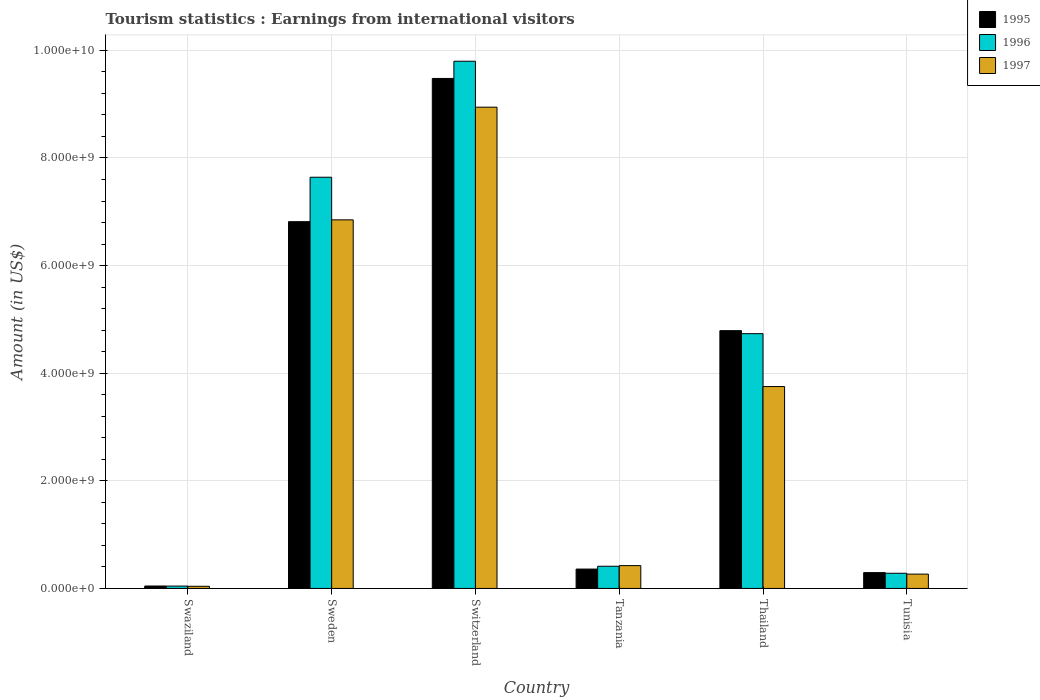How many different coloured bars are there?
Your answer should be compact. 3. How many groups of bars are there?
Provide a succinct answer. 6. Are the number of bars per tick equal to the number of legend labels?
Make the answer very short. Yes. Are the number of bars on each tick of the X-axis equal?
Your response must be concise. Yes. How many bars are there on the 4th tick from the left?
Make the answer very short. 3. How many bars are there on the 6th tick from the right?
Make the answer very short. 3. What is the label of the 2nd group of bars from the left?
Your answer should be compact. Sweden. In how many cases, is the number of bars for a given country not equal to the number of legend labels?
Provide a short and direct response. 0. What is the earnings from international visitors in 1995 in Switzerland?
Keep it short and to the point. 9.48e+09. Across all countries, what is the maximum earnings from international visitors in 1997?
Offer a very short reply. 8.94e+09. Across all countries, what is the minimum earnings from international visitors in 1997?
Keep it short and to the point. 4.00e+07. In which country was the earnings from international visitors in 1995 maximum?
Offer a terse response. Switzerland. In which country was the earnings from international visitors in 1996 minimum?
Offer a very short reply. Swaziland. What is the total earnings from international visitors in 1995 in the graph?
Offer a very short reply. 2.18e+1. What is the difference between the earnings from international visitors in 1995 in Tanzania and that in Thailand?
Offer a terse response. -4.43e+09. What is the difference between the earnings from international visitors in 1996 in Thailand and the earnings from international visitors in 1995 in Swaziland?
Provide a short and direct response. 4.69e+09. What is the average earnings from international visitors in 1997 per country?
Ensure brevity in your answer.  3.38e+09. What is the difference between the earnings from international visitors of/in 1997 and earnings from international visitors of/in 1995 in Thailand?
Make the answer very short. -1.04e+09. Is the earnings from international visitors in 1995 in Swaziland less than that in Tunisia?
Your answer should be very brief. Yes. What is the difference between the highest and the second highest earnings from international visitors in 1996?
Keep it short and to the point. 2.16e+09. What is the difference between the highest and the lowest earnings from international visitors in 1997?
Your response must be concise. 8.90e+09. In how many countries, is the earnings from international visitors in 1996 greater than the average earnings from international visitors in 1996 taken over all countries?
Ensure brevity in your answer.  3. Are all the bars in the graph horizontal?
Offer a very short reply. No. Does the graph contain any zero values?
Your response must be concise. No. How many legend labels are there?
Ensure brevity in your answer.  3. What is the title of the graph?
Offer a terse response. Tourism statistics : Earnings from international visitors. What is the label or title of the Y-axis?
Make the answer very short. Amount (in US$). What is the Amount (in US$) in 1995 in Swaziland?
Give a very brief answer. 4.50e+07. What is the Amount (in US$) in 1996 in Swaziland?
Offer a terse response. 4.40e+07. What is the Amount (in US$) of 1997 in Swaziland?
Keep it short and to the point. 4.00e+07. What is the Amount (in US$) of 1995 in Sweden?
Make the answer very short. 6.82e+09. What is the Amount (in US$) in 1996 in Sweden?
Keep it short and to the point. 7.64e+09. What is the Amount (in US$) of 1997 in Sweden?
Provide a short and direct response. 6.85e+09. What is the Amount (in US$) in 1995 in Switzerland?
Offer a very short reply. 9.48e+09. What is the Amount (in US$) in 1996 in Switzerland?
Provide a succinct answer. 9.80e+09. What is the Amount (in US$) in 1997 in Switzerland?
Offer a very short reply. 8.94e+09. What is the Amount (in US$) of 1995 in Tanzania?
Make the answer very short. 3.60e+08. What is the Amount (in US$) in 1996 in Tanzania?
Offer a very short reply. 4.12e+08. What is the Amount (in US$) of 1997 in Tanzania?
Provide a short and direct response. 4.24e+08. What is the Amount (in US$) in 1995 in Thailand?
Your response must be concise. 4.79e+09. What is the Amount (in US$) of 1996 in Thailand?
Offer a very short reply. 4.74e+09. What is the Amount (in US$) in 1997 in Thailand?
Provide a short and direct response. 3.75e+09. What is the Amount (in US$) of 1995 in Tunisia?
Ensure brevity in your answer.  2.94e+08. What is the Amount (in US$) of 1996 in Tunisia?
Ensure brevity in your answer.  2.82e+08. What is the Amount (in US$) in 1997 in Tunisia?
Give a very brief answer. 2.66e+08. Across all countries, what is the maximum Amount (in US$) in 1995?
Provide a short and direct response. 9.48e+09. Across all countries, what is the maximum Amount (in US$) in 1996?
Offer a terse response. 9.80e+09. Across all countries, what is the maximum Amount (in US$) in 1997?
Offer a terse response. 8.94e+09. Across all countries, what is the minimum Amount (in US$) in 1995?
Your answer should be compact. 4.50e+07. Across all countries, what is the minimum Amount (in US$) in 1996?
Ensure brevity in your answer.  4.40e+07. Across all countries, what is the minimum Amount (in US$) in 1997?
Your response must be concise. 4.00e+07. What is the total Amount (in US$) of 1995 in the graph?
Your answer should be very brief. 2.18e+1. What is the total Amount (in US$) of 1996 in the graph?
Provide a succinct answer. 2.29e+1. What is the total Amount (in US$) of 1997 in the graph?
Make the answer very short. 2.03e+1. What is the difference between the Amount (in US$) of 1995 in Swaziland and that in Sweden?
Your response must be concise. -6.77e+09. What is the difference between the Amount (in US$) in 1996 in Swaziland and that in Sweden?
Your answer should be very brief. -7.60e+09. What is the difference between the Amount (in US$) of 1997 in Swaziland and that in Sweden?
Ensure brevity in your answer.  -6.81e+09. What is the difference between the Amount (in US$) in 1995 in Swaziland and that in Switzerland?
Offer a very short reply. -9.43e+09. What is the difference between the Amount (in US$) of 1996 in Swaziland and that in Switzerland?
Ensure brevity in your answer.  -9.75e+09. What is the difference between the Amount (in US$) in 1997 in Swaziland and that in Switzerland?
Your response must be concise. -8.90e+09. What is the difference between the Amount (in US$) of 1995 in Swaziland and that in Tanzania?
Ensure brevity in your answer.  -3.15e+08. What is the difference between the Amount (in US$) in 1996 in Swaziland and that in Tanzania?
Give a very brief answer. -3.68e+08. What is the difference between the Amount (in US$) in 1997 in Swaziland and that in Tanzania?
Offer a very short reply. -3.84e+08. What is the difference between the Amount (in US$) of 1995 in Swaziland and that in Thailand?
Offer a terse response. -4.75e+09. What is the difference between the Amount (in US$) of 1996 in Swaziland and that in Thailand?
Your response must be concise. -4.69e+09. What is the difference between the Amount (in US$) in 1997 in Swaziland and that in Thailand?
Provide a short and direct response. -3.71e+09. What is the difference between the Amount (in US$) of 1995 in Swaziland and that in Tunisia?
Ensure brevity in your answer.  -2.49e+08. What is the difference between the Amount (in US$) in 1996 in Swaziland and that in Tunisia?
Keep it short and to the point. -2.38e+08. What is the difference between the Amount (in US$) in 1997 in Swaziland and that in Tunisia?
Give a very brief answer. -2.26e+08. What is the difference between the Amount (in US$) of 1995 in Sweden and that in Switzerland?
Make the answer very short. -2.66e+09. What is the difference between the Amount (in US$) in 1996 in Sweden and that in Switzerland?
Provide a short and direct response. -2.16e+09. What is the difference between the Amount (in US$) in 1997 in Sweden and that in Switzerland?
Your response must be concise. -2.09e+09. What is the difference between the Amount (in US$) of 1995 in Sweden and that in Tanzania?
Your response must be concise. 6.46e+09. What is the difference between the Amount (in US$) of 1996 in Sweden and that in Tanzania?
Keep it short and to the point. 7.23e+09. What is the difference between the Amount (in US$) of 1997 in Sweden and that in Tanzania?
Provide a succinct answer. 6.43e+09. What is the difference between the Amount (in US$) in 1995 in Sweden and that in Thailand?
Your response must be concise. 2.02e+09. What is the difference between the Amount (in US$) in 1996 in Sweden and that in Thailand?
Give a very brief answer. 2.91e+09. What is the difference between the Amount (in US$) in 1997 in Sweden and that in Thailand?
Offer a terse response. 3.10e+09. What is the difference between the Amount (in US$) in 1995 in Sweden and that in Tunisia?
Your answer should be compact. 6.52e+09. What is the difference between the Amount (in US$) of 1996 in Sweden and that in Tunisia?
Offer a very short reply. 7.36e+09. What is the difference between the Amount (in US$) of 1997 in Sweden and that in Tunisia?
Make the answer very short. 6.58e+09. What is the difference between the Amount (in US$) in 1995 in Switzerland and that in Tanzania?
Provide a succinct answer. 9.12e+09. What is the difference between the Amount (in US$) in 1996 in Switzerland and that in Tanzania?
Offer a very short reply. 9.39e+09. What is the difference between the Amount (in US$) in 1997 in Switzerland and that in Tanzania?
Give a very brief answer. 8.52e+09. What is the difference between the Amount (in US$) in 1995 in Switzerland and that in Thailand?
Provide a succinct answer. 4.69e+09. What is the difference between the Amount (in US$) of 1996 in Switzerland and that in Thailand?
Your response must be concise. 5.06e+09. What is the difference between the Amount (in US$) of 1997 in Switzerland and that in Thailand?
Offer a very short reply. 5.19e+09. What is the difference between the Amount (in US$) of 1995 in Switzerland and that in Tunisia?
Your response must be concise. 9.18e+09. What is the difference between the Amount (in US$) in 1996 in Switzerland and that in Tunisia?
Keep it short and to the point. 9.52e+09. What is the difference between the Amount (in US$) in 1997 in Switzerland and that in Tunisia?
Your answer should be compact. 8.68e+09. What is the difference between the Amount (in US$) of 1995 in Tanzania and that in Thailand?
Provide a short and direct response. -4.43e+09. What is the difference between the Amount (in US$) in 1996 in Tanzania and that in Thailand?
Offer a terse response. -4.32e+09. What is the difference between the Amount (in US$) in 1997 in Tanzania and that in Thailand?
Ensure brevity in your answer.  -3.33e+09. What is the difference between the Amount (in US$) in 1995 in Tanzania and that in Tunisia?
Your answer should be very brief. 6.60e+07. What is the difference between the Amount (in US$) in 1996 in Tanzania and that in Tunisia?
Your response must be concise. 1.30e+08. What is the difference between the Amount (in US$) of 1997 in Tanzania and that in Tunisia?
Your response must be concise. 1.58e+08. What is the difference between the Amount (in US$) of 1995 in Thailand and that in Tunisia?
Give a very brief answer. 4.50e+09. What is the difference between the Amount (in US$) in 1996 in Thailand and that in Tunisia?
Your answer should be compact. 4.45e+09. What is the difference between the Amount (in US$) of 1997 in Thailand and that in Tunisia?
Offer a very short reply. 3.49e+09. What is the difference between the Amount (in US$) of 1995 in Swaziland and the Amount (in US$) of 1996 in Sweden?
Your answer should be compact. -7.60e+09. What is the difference between the Amount (in US$) of 1995 in Swaziland and the Amount (in US$) of 1997 in Sweden?
Offer a very short reply. -6.80e+09. What is the difference between the Amount (in US$) in 1996 in Swaziland and the Amount (in US$) in 1997 in Sweden?
Provide a short and direct response. -6.81e+09. What is the difference between the Amount (in US$) of 1995 in Swaziland and the Amount (in US$) of 1996 in Switzerland?
Keep it short and to the point. -9.75e+09. What is the difference between the Amount (in US$) in 1995 in Swaziland and the Amount (in US$) in 1997 in Switzerland?
Provide a succinct answer. -8.90e+09. What is the difference between the Amount (in US$) of 1996 in Swaziland and the Amount (in US$) of 1997 in Switzerland?
Provide a succinct answer. -8.90e+09. What is the difference between the Amount (in US$) of 1995 in Swaziland and the Amount (in US$) of 1996 in Tanzania?
Make the answer very short. -3.67e+08. What is the difference between the Amount (in US$) in 1995 in Swaziland and the Amount (in US$) in 1997 in Tanzania?
Offer a terse response. -3.79e+08. What is the difference between the Amount (in US$) of 1996 in Swaziland and the Amount (in US$) of 1997 in Tanzania?
Your response must be concise. -3.80e+08. What is the difference between the Amount (in US$) of 1995 in Swaziland and the Amount (in US$) of 1996 in Thailand?
Provide a succinct answer. -4.69e+09. What is the difference between the Amount (in US$) in 1995 in Swaziland and the Amount (in US$) in 1997 in Thailand?
Keep it short and to the point. -3.71e+09. What is the difference between the Amount (in US$) in 1996 in Swaziland and the Amount (in US$) in 1997 in Thailand?
Keep it short and to the point. -3.71e+09. What is the difference between the Amount (in US$) in 1995 in Swaziland and the Amount (in US$) in 1996 in Tunisia?
Your answer should be compact. -2.37e+08. What is the difference between the Amount (in US$) of 1995 in Swaziland and the Amount (in US$) of 1997 in Tunisia?
Your answer should be compact. -2.21e+08. What is the difference between the Amount (in US$) in 1996 in Swaziland and the Amount (in US$) in 1997 in Tunisia?
Ensure brevity in your answer.  -2.22e+08. What is the difference between the Amount (in US$) of 1995 in Sweden and the Amount (in US$) of 1996 in Switzerland?
Make the answer very short. -2.98e+09. What is the difference between the Amount (in US$) of 1995 in Sweden and the Amount (in US$) of 1997 in Switzerland?
Your answer should be very brief. -2.13e+09. What is the difference between the Amount (in US$) in 1996 in Sweden and the Amount (in US$) in 1997 in Switzerland?
Provide a succinct answer. -1.30e+09. What is the difference between the Amount (in US$) in 1995 in Sweden and the Amount (in US$) in 1996 in Tanzania?
Your answer should be very brief. 6.40e+09. What is the difference between the Amount (in US$) of 1995 in Sweden and the Amount (in US$) of 1997 in Tanzania?
Offer a terse response. 6.39e+09. What is the difference between the Amount (in US$) in 1996 in Sweden and the Amount (in US$) in 1997 in Tanzania?
Provide a short and direct response. 7.22e+09. What is the difference between the Amount (in US$) in 1995 in Sweden and the Amount (in US$) in 1996 in Thailand?
Give a very brief answer. 2.08e+09. What is the difference between the Amount (in US$) in 1995 in Sweden and the Amount (in US$) in 1997 in Thailand?
Offer a terse response. 3.06e+09. What is the difference between the Amount (in US$) in 1996 in Sweden and the Amount (in US$) in 1997 in Thailand?
Your answer should be compact. 3.89e+09. What is the difference between the Amount (in US$) of 1995 in Sweden and the Amount (in US$) of 1996 in Tunisia?
Your response must be concise. 6.53e+09. What is the difference between the Amount (in US$) of 1995 in Sweden and the Amount (in US$) of 1997 in Tunisia?
Make the answer very short. 6.55e+09. What is the difference between the Amount (in US$) of 1996 in Sweden and the Amount (in US$) of 1997 in Tunisia?
Your answer should be very brief. 7.38e+09. What is the difference between the Amount (in US$) of 1995 in Switzerland and the Amount (in US$) of 1996 in Tanzania?
Your answer should be compact. 9.07e+09. What is the difference between the Amount (in US$) of 1995 in Switzerland and the Amount (in US$) of 1997 in Tanzania?
Offer a very short reply. 9.05e+09. What is the difference between the Amount (in US$) in 1996 in Switzerland and the Amount (in US$) in 1997 in Tanzania?
Offer a very short reply. 9.37e+09. What is the difference between the Amount (in US$) of 1995 in Switzerland and the Amount (in US$) of 1996 in Thailand?
Provide a short and direct response. 4.74e+09. What is the difference between the Amount (in US$) in 1995 in Switzerland and the Amount (in US$) in 1997 in Thailand?
Provide a short and direct response. 5.73e+09. What is the difference between the Amount (in US$) of 1996 in Switzerland and the Amount (in US$) of 1997 in Thailand?
Keep it short and to the point. 6.05e+09. What is the difference between the Amount (in US$) of 1995 in Switzerland and the Amount (in US$) of 1996 in Tunisia?
Your response must be concise. 9.20e+09. What is the difference between the Amount (in US$) in 1995 in Switzerland and the Amount (in US$) in 1997 in Tunisia?
Your response must be concise. 9.21e+09. What is the difference between the Amount (in US$) of 1996 in Switzerland and the Amount (in US$) of 1997 in Tunisia?
Make the answer very short. 9.53e+09. What is the difference between the Amount (in US$) of 1995 in Tanzania and the Amount (in US$) of 1996 in Thailand?
Your answer should be very brief. -4.38e+09. What is the difference between the Amount (in US$) in 1995 in Tanzania and the Amount (in US$) in 1997 in Thailand?
Give a very brief answer. -3.39e+09. What is the difference between the Amount (in US$) in 1996 in Tanzania and the Amount (in US$) in 1997 in Thailand?
Offer a very short reply. -3.34e+09. What is the difference between the Amount (in US$) in 1995 in Tanzania and the Amount (in US$) in 1996 in Tunisia?
Provide a short and direct response. 7.80e+07. What is the difference between the Amount (in US$) of 1995 in Tanzania and the Amount (in US$) of 1997 in Tunisia?
Offer a very short reply. 9.40e+07. What is the difference between the Amount (in US$) in 1996 in Tanzania and the Amount (in US$) in 1997 in Tunisia?
Ensure brevity in your answer.  1.46e+08. What is the difference between the Amount (in US$) in 1995 in Thailand and the Amount (in US$) in 1996 in Tunisia?
Your response must be concise. 4.51e+09. What is the difference between the Amount (in US$) in 1995 in Thailand and the Amount (in US$) in 1997 in Tunisia?
Offer a terse response. 4.52e+09. What is the difference between the Amount (in US$) of 1996 in Thailand and the Amount (in US$) of 1997 in Tunisia?
Your answer should be compact. 4.47e+09. What is the average Amount (in US$) of 1995 per country?
Offer a very short reply. 3.63e+09. What is the average Amount (in US$) in 1996 per country?
Keep it short and to the point. 3.82e+09. What is the average Amount (in US$) in 1997 per country?
Your answer should be compact. 3.38e+09. What is the difference between the Amount (in US$) in 1995 and Amount (in US$) in 1996 in Sweden?
Give a very brief answer. -8.26e+08. What is the difference between the Amount (in US$) in 1995 and Amount (in US$) in 1997 in Sweden?
Ensure brevity in your answer.  -3.40e+07. What is the difference between the Amount (in US$) of 1996 and Amount (in US$) of 1997 in Sweden?
Ensure brevity in your answer.  7.92e+08. What is the difference between the Amount (in US$) in 1995 and Amount (in US$) in 1996 in Switzerland?
Ensure brevity in your answer.  -3.20e+08. What is the difference between the Amount (in US$) in 1995 and Amount (in US$) in 1997 in Switzerland?
Make the answer very short. 5.34e+08. What is the difference between the Amount (in US$) of 1996 and Amount (in US$) of 1997 in Switzerland?
Your answer should be very brief. 8.54e+08. What is the difference between the Amount (in US$) in 1995 and Amount (in US$) in 1996 in Tanzania?
Keep it short and to the point. -5.20e+07. What is the difference between the Amount (in US$) of 1995 and Amount (in US$) of 1997 in Tanzania?
Give a very brief answer. -6.40e+07. What is the difference between the Amount (in US$) of 1996 and Amount (in US$) of 1997 in Tanzania?
Provide a succinct answer. -1.20e+07. What is the difference between the Amount (in US$) of 1995 and Amount (in US$) of 1996 in Thailand?
Keep it short and to the point. 5.60e+07. What is the difference between the Amount (in US$) of 1995 and Amount (in US$) of 1997 in Thailand?
Give a very brief answer. 1.04e+09. What is the difference between the Amount (in US$) in 1996 and Amount (in US$) in 1997 in Thailand?
Your answer should be compact. 9.83e+08. What is the difference between the Amount (in US$) of 1995 and Amount (in US$) of 1996 in Tunisia?
Offer a terse response. 1.20e+07. What is the difference between the Amount (in US$) in 1995 and Amount (in US$) in 1997 in Tunisia?
Offer a terse response. 2.80e+07. What is the difference between the Amount (in US$) in 1996 and Amount (in US$) in 1997 in Tunisia?
Keep it short and to the point. 1.60e+07. What is the ratio of the Amount (in US$) of 1995 in Swaziland to that in Sweden?
Your answer should be compact. 0.01. What is the ratio of the Amount (in US$) in 1996 in Swaziland to that in Sweden?
Give a very brief answer. 0.01. What is the ratio of the Amount (in US$) of 1997 in Swaziland to that in Sweden?
Provide a succinct answer. 0.01. What is the ratio of the Amount (in US$) of 1995 in Swaziland to that in Switzerland?
Keep it short and to the point. 0. What is the ratio of the Amount (in US$) of 1996 in Swaziland to that in Switzerland?
Your response must be concise. 0. What is the ratio of the Amount (in US$) in 1997 in Swaziland to that in Switzerland?
Offer a very short reply. 0. What is the ratio of the Amount (in US$) in 1995 in Swaziland to that in Tanzania?
Your answer should be compact. 0.12. What is the ratio of the Amount (in US$) of 1996 in Swaziland to that in Tanzania?
Offer a terse response. 0.11. What is the ratio of the Amount (in US$) in 1997 in Swaziland to that in Tanzania?
Your answer should be compact. 0.09. What is the ratio of the Amount (in US$) of 1995 in Swaziland to that in Thailand?
Offer a very short reply. 0.01. What is the ratio of the Amount (in US$) of 1996 in Swaziland to that in Thailand?
Your response must be concise. 0.01. What is the ratio of the Amount (in US$) in 1997 in Swaziland to that in Thailand?
Give a very brief answer. 0.01. What is the ratio of the Amount (in US$) of 1995 in Swaziland to that in Tunisia?
Make the answer very short. 0.15. What is the ratio of the Amount (in US$) in 1996 in Swaziland to that in Tunisia?
Offer a terse response. 0.16. What is the ratio of the Amount (in US$) in 1997 in Swaziland to that in Tunisia?
Provide a succinct answer. 0.15. What is the ratio of the Amount (in US$) of 1995 in Sweden to that in Switzerland?
Keep it short and to the point. 0.72. What is the ratio of the Amount (in US$) of 1996 in Sweden to that in Switzerland?
Your answer should be compact. 0.78. What is the ratio of the Amount (in US$) in 1997 in Sweden to that in Switzerland?
Offer a very short reply. 0.77. What is the ratio of the Amount (in US$) in 1995 in Sweden to that in Tanzania?
Your answer should be very brief. 18.93. What is the ratio of the Amount (in US$) in 1996 in Sweden to that in Tanzania?
Provide a succinct answer. 18.55. What is the ratio of the Amount (in US$) of 1997 in Sweden to that in Tanzania?
Your answer should be compact. 16.16. What is the ratio of the Amount (in US$) in 1995 in Sweden to that in Thailand?
Offer a very short reply. 1.42. What is the ratio of the Amount (in US$) of 1996 in Sweden to that in Thailand?
Provide a succinct answer. 1.61. What is the ratio of the Amount (in US$) in 1997 in Sweden to that in Thailand?
Offer a very short reply. 1.83. What is the ratio of the Amount (in US$) in 1995 in Sweden to that in Tunisia?
Offer a terse response. 23.18. What is the ratio of the Amount (in US$) in 1996 in Sweden to that in Tunisia?
Your response must be concise. 27.1. What is the ratio of the Amount (in US$) of 1997 in Sweden to that in Tunisia?
Your answer should be compact. 25.75. What is the ratio of the Amount (in US$) in 1995 in Switzerland to that in Tanzania?
Ensure brevity in your answer.  26.33. What is the ratio of the Amount (in US$) of 1996 in Switzerland to that in Tanzania?
Your answer should be compact. 23.78. What is the ratio of the Amount (in US$) of 1997 in Switzerland to that in Tanzania?
Give a very brief answer. 21.09. What is the ratio of the Amount (in US$) in 1995 in Switzerland to that in Thailand?
Provide a succinct answer. 1.98. What is the ratio of the Amount (in US$) in 1996 in Switzerland to that in Thailand?
Your response must be concise. 2.07. What is the ratio of the Amount (in US$) of 1997 in Switzerland to that in Thailand?
Keep it short and to the point. 2.38. What is the ratio of the Amount (in US$) of 1995 in Switzerland to that in Tunisia?
Ensure brevity in your answer.  32.24. What is the ratio of the Amount (in US$) in 1996 in Switzerland to that in Tunisia?
Ensure brevity in your answer.  34.74. What is the ratio of the Amount (in US$) in 1997 in Switzerland to that in Tunisia?
Your answer should be compact. 33.62. What is the ratio of the Amount (in US$) in 1995 in Tanzania to that in Thailand?
Provide a short and direct response. 0.08. What is the ratio of the Amount (in US$) in 1996 in Tanzania to that in Thailand?
Offer a very short reply. 0.09. What is the ratio of the Amount (in US$) in 1997 in Tanzania to that in Thailand?
Ensure brevity in your answer.  0.11. What is the ratio of the Amount (in US$) of 1995 in Tanzania to that in Tunisia?
Keep it short and to the point. 1.22. What is the ratio of the Amount (in US$) of 1996 in Tanzania to that in Tunisia?
Provide a succinct answer. 1.46. What is the ratio of the Amount (in US$) of 1997 in Tanzania to that in Tunisia?
Give a very brief answer. 1.59. What is the ratio of the Amount (in US$) in 1995 in Thailand to that in Tunisia?
Keep it short and to the point. 16.3. What is the ratio of the Amount (in US$) in 1996 in Thailand to that in Tunisia?
Ensure brevity in your answer.  16.79. What is the ratio of the Amount (in US$) in 1997 in Thailand to that in Tunisia?
Ensure brevity in your answer.  14.11. What is the difference between the highest and the second highest Amount (in US$) of 1995?
Make the answer very short. 2.66e+09. What is the difference between the highest and the second highest Amount (in US$) of 1996?
Your answer should be compact. 2.16e+09. What is the difference between the highest and the second highest Amount (in US$) of 1997?
Provide a succinct answer. 2.09e+09. What is the difference between the highest and the lowest Amount (in US$) in 1995?
Make the answer very short. 9.43e+09. What is the difference between the highest and the lowest Amount (in US$) of 1996?
Keep it short and to the point. 9.75e+09. What is the difference between the highest and the lowest Amount (in US$) in 1997?
Offer a very short reply. 8.90e+09. 